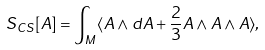<formula> <loc_0><loc_0><loc_500><loc_500>S _ { C S } [ A ] = \int _ { M } \langle A \wedge d A + \frac { 2 } { 3 } A \wedge A \wedge A \rangle ,</formula> 